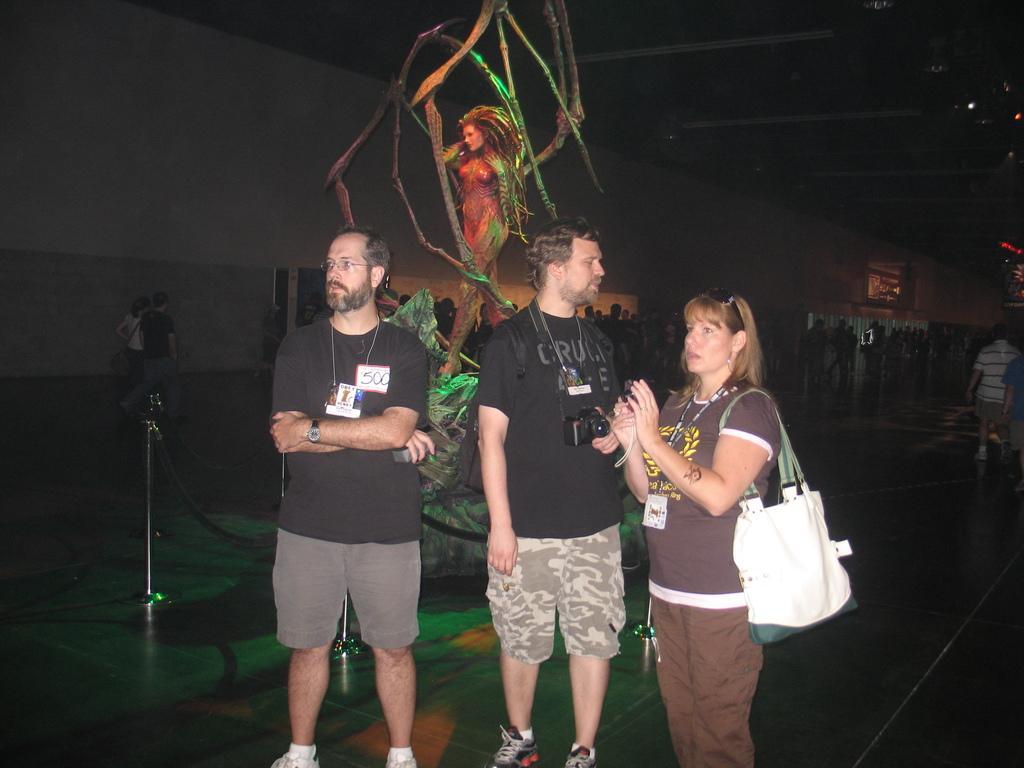Describe this image in one or two sentences. This is a picture taken in a dark background , The three people were standing on the floor the woman carrying a white hand bag and holding a camera and the two men's are in black t shirts the man in black t shirt with spectacles having a watch to his right hand and the back ground of this three person there is a sculpture of the women. 